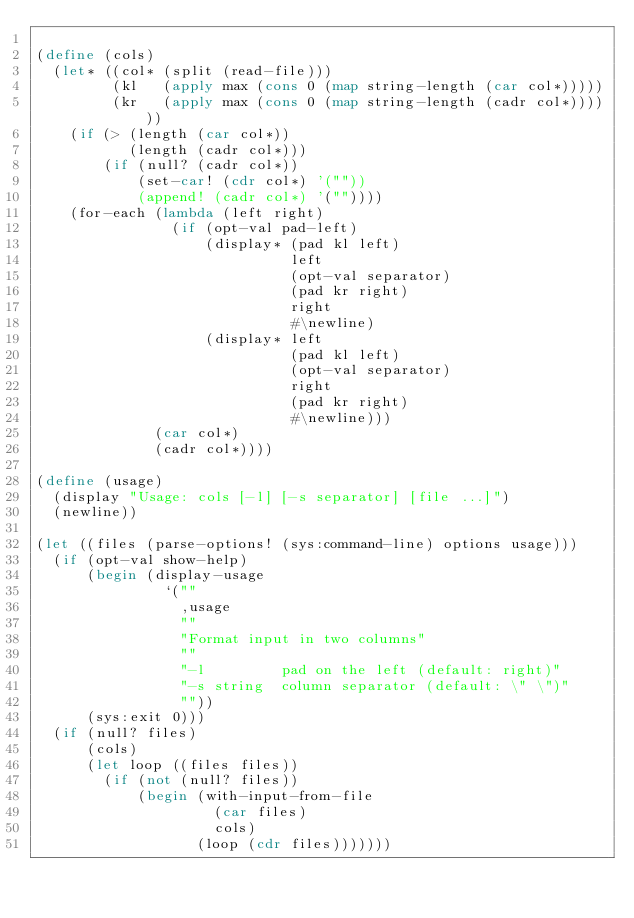Convert code to text. <code><loc_0><loc_0><loc_500><loc_500><_Scheme_>
(define (cols)
  (let* ((col* (split (read-file)))
         (kl   (apply max (cons 0 (map string-length (car col*)))))
         (kr   (apply max (cons 0 (map string-length (cadr col*))))))
    (if (> (length (car col*))
           (length (cadr col*)))
        (if (null? (cadr col*))
            (set-car! (cdr col*) '(""))
            (append! (cadr col*) '(""))))
    (for-each (lambda (left right)
                (if (opt-val pad-left)
                    (display* (pad kl left)
                              left
                              (opt-val separator)
                              (pad kr right)
                              right
                              #\newline)
                    (display* left
                              (pad kl left)
                              (opt-val separator)
                              right
                              (pad kr right)
                              #\newline)))
              (car col*)
              (cadr col*))))

(define (usage)
  (display "Usage: cols [-l] [-s separator] [file ...]")
  (newline))

(let ((files (parse-options! (sys:command-line) options usage)))
  (if (opt-val show-help)
      (begin (display-usage
               `(""
                 ,usage
                 ""
                 "Format input in two columns"
                 ""
                 "-l         pad on the left (default: right)"
                 "-s string  column separator (default: \" \")"
                 ""))
      (sys:exit 0)))
  (if (null? files)
      (cols)
      (let loop ((files files))
        (if (not (null? files))
            (begin (with-input-from-file
                     (car files)
                     cols)
                   (loop (cdr files)))))))
</code> 